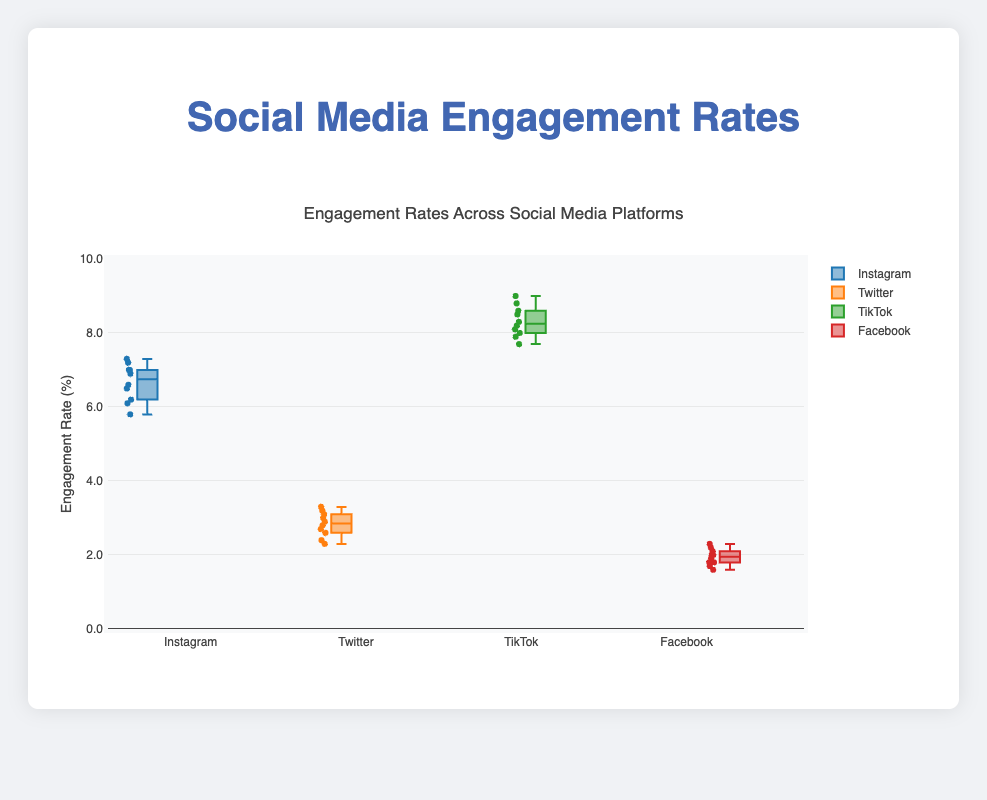What is the title of the figure? The title is located at the top of the plot and usually summarizes the main topic of the figure. By looking at the top part of the plot, we see it reads "Engagement Rates Across Social Media Platforms".
Answer: Engagement Rates Across Social Media Platforms How many social media platforms are compared in the plot? Each box in a box plot represents a different group or platform. By counting the number of boxes in the figure, we see that there are four platforms being compared: Instagram, Twitter, TikTok, and Facebook.
Answer: Four Which social media platform has the highest median engagement rate? The median in a box plot is represented by the line inside each box. By examining the boxes, the line in the TikTok box is positioned higher than those of the other platforms, indicating the highest median engagement rate.
Answer: TikTok What is the range of engagement rates for Instagram? The range of a dataset in a box plot is indicated by the distance between the lowest (minimum) and highest (maximum) points excluding any potential outliers. For Instagram, we look at the bottom and top whiskers of its box. The values are approximately 5.8 (min) and 7.3 (max).
Answer: Approximately 5.8 to 7.3 Compare the interquartile range (IQR) of Twitter and Facebook. Which has a larger IQR? The interquartile range (IQR) is the distance between the first quartile (Q1) and the third quartile (Q3). It is the length of the box. By comparing the box lengths visually, Twitter's box is longer than Facebook’s.
Answer: Twitter What is the median engagement rate for Facebook? The median value in a box plot is indicated by the line within the box. For Facebook, the median line appears to be close to 1.9.
Answer: Approximately 1.9 Which platform has the most variability in engagement rates? Variability can be judged by the spread of the data points. The box plot with the widest box and longest whiskers indicates the greatest variability. TikTok's spread is the largest, showing the most variability.
Answer: TikTok Are there any outliers in the data for any platform? Outliers in a box plot are shown as individual points outside the whiskers. Inspecting the plot for individual points away from the whiskers, we see no outliers present.
Answer: No What is the difference between the highest and lowest engagement rates for TikTok? The range can be determined by subtracting the minimum value from the maximum value. For TikTok, the minimum is approximately 7.7, and the maximum is approximately 9.0: 9.0 - 7.7 = 1.3.
Answer: 1.3 Which platform shows the highest minimum engagement rate? The minimum engagement rate in a box plot is indicated by the bottom whisker. TikTok's bottom whisker starts higher than those of the other platforms, indicating the highest minimum engagement rate.
Answer: TikTok 